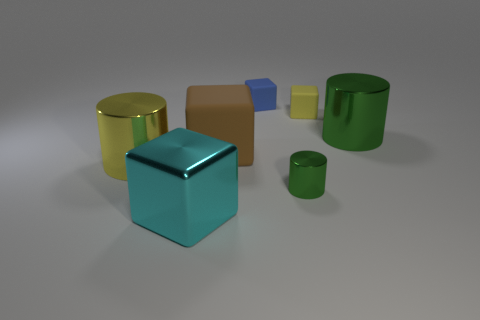Do the big metallic cylinder that is to the right of the tiny yellow object and the small object in front of the large brown thing have the same color?
Give a very brief answer. Yes. What number of red matte balls are there?
Make the answer very short. 0. Are there any brown objects right of the large cyan object?
Give a very brief answer. Yes. Is the material of the small thing in front of the big yellow object the same as the big cylinder that is on the left side of the large brown cube?
Keep it short and to the point. Yes. Is the number of small things that are in front of the small yellow cube less than the number of blue rubber blocks?
Ensure brevity in your answer.  No. The big block behind the cyan metal thing is what color?
Your answer should be compact. Brown. What material is the green thing that is to the left of the tiny rubber object to the right of the tiny blue cube?
Your answer should be compact. Metal. Is there a yellow object that has the same size as the cyan cube?
Offer a very short reply. Yes. What number of things are cylinders that are on the left side of the cyan shiny cube or metal cylinders that are to the left of the tiny blue cube?
Make the answer very short. 1. There is a yellow rubber block that is right of the cyan thing; is it the same size as the green metallic cylinder right of the tiny yellow block?
Your response must be concise. No. 